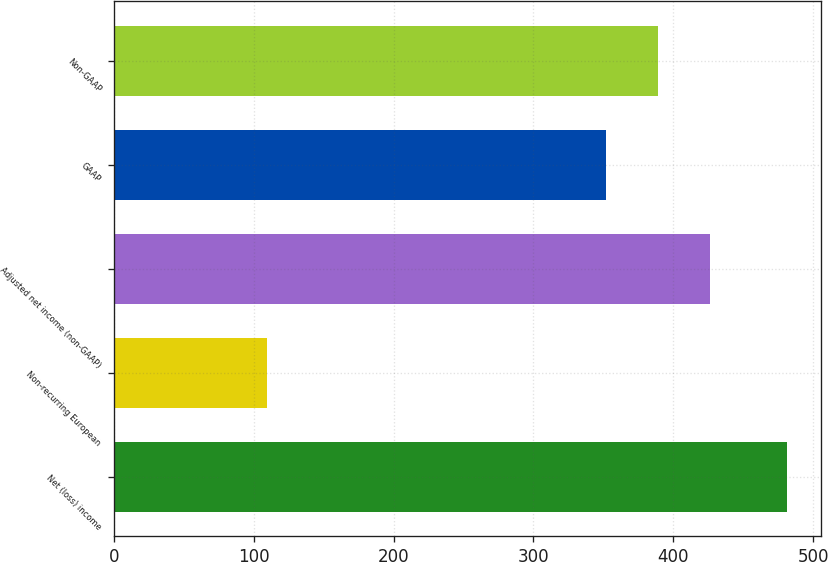Convert chart to OTSL. <chart><loc_0><loc_0><loc_500><loc_500><bar_chart><fcel>Net (loss) income<fcel>Non-recurring European<fcel>Adjusted net income (non-GAAP)<fcel>GAAP<fcel>Non-GAAP<nl><fcel>481.3<fcel>109.6<fcel>425.94<fcel>351.6<fcel>388.77<nl></chart> 